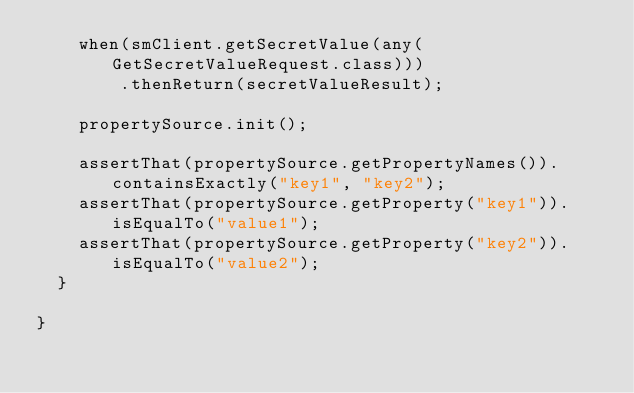Convert code to text. <code><loc_0><loc_0><loc_500><loc_500><_Java_>		when(smClient.getSecretValue(any(GetSecretValueRequest.class)))
				.thenReturn(secretValueResult);

		propertySource.init();

		assertThat(propertySource.getPropertyNames()).containsExactly("key1", "key2");
		assertThat(propertySource.getProperty("key1")).isEqualTo("value1");
		assertThat(propertySource.getProperty("key2")).isEqualTo("value2");
	}

}
</code> 